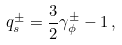<formula> <loc_0><loc_0><loc_500><loc_500>q _ { s } ^ { \pm } = \frac { 3 } { 2 } \gamma _ { \phi } ^ { \pm } - 1 \, ,</formula> 